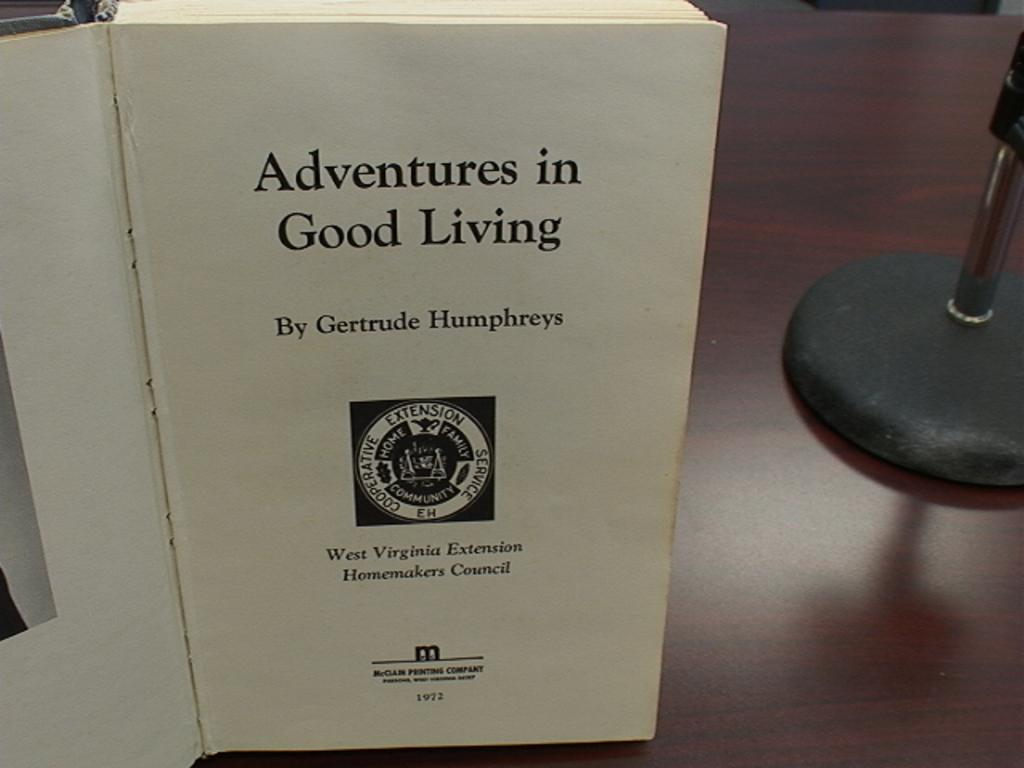<image>
Give a short and clear explanation of the subsequent image. First page of a book named "Adventures in Good Living". 